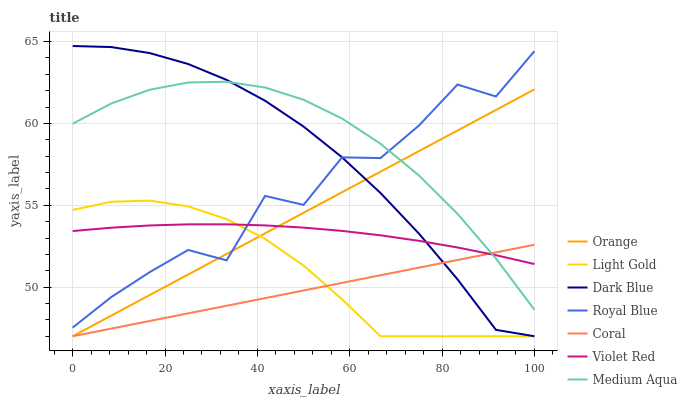Does Coral have the minimum area under the curve?
Answer yes or no. Yes. Does Medium Aqua have the maximum area under the curve?
Answer yes or no. Yes. Does Royal Blue have the minimum area under the curve?
Answer yes or no. No. Does Royal Blue have the maximum area under the curve?
Answer yes or no. No. Is Orange the smoothest?
Answer yes or no. Yes. Is Royal Blue the roughest?
Answer yes or no. Yes. Is Coral the smoothest?
Answer yes or no. No. Is Coral the roughest?
Answer yes or no. No. Does Coral have the lowest value?
Answer yes or no. Yes. Does Royal Blue have the lowest value?
Answer yes or no. No. Does Dark Blue have the highest value?
Answer yes or no. Yes. Does Royal Blue have the highest value?
Answer yes or no. No. Is Coral less than Royal Blue?
Answer yes or no. Yes. Is Medium Aqua greater than Light Gold?
Answer yes or no. Yes. Does Orange intersect Dark Blue?
Answer yes or no. Yes. Is Orange less than Dark Blue?
Answer yes or no. No. Is Orange greater than Dark Blue?
Answer yes or no. No. Does Coral intersect Royal Blue?
Answer yes or no. No. 